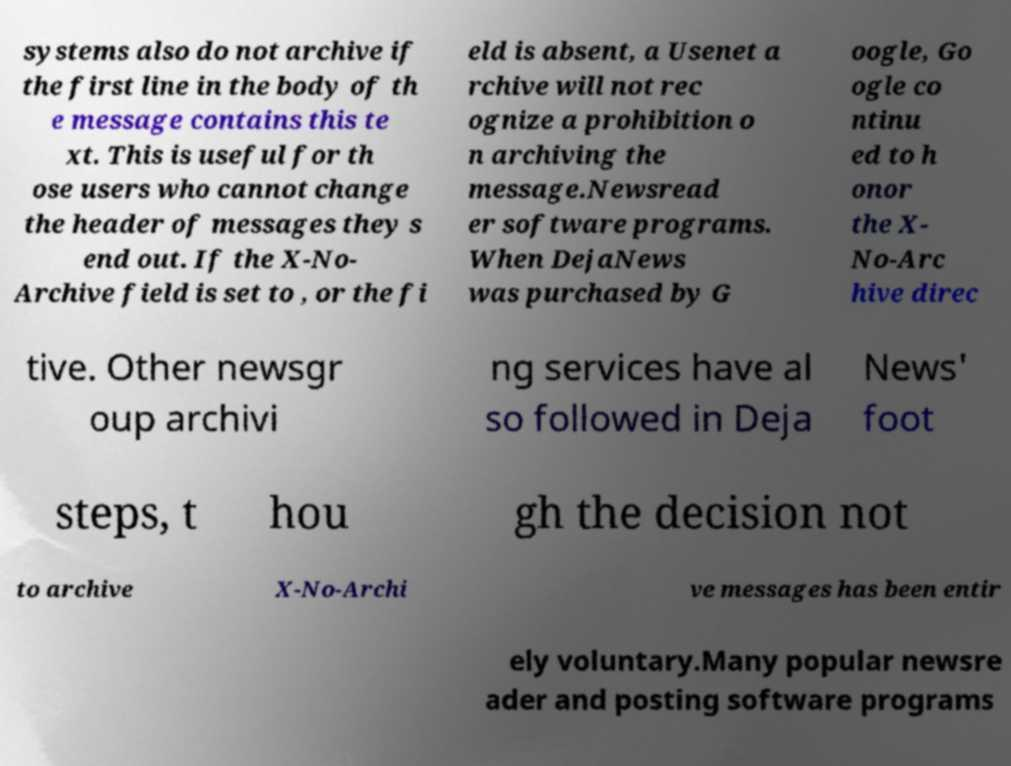There's text embedded in this image that I need extracted. Can you transcribe it verbatim? systems also do not archive if the first line in the body of th e message contains this te xt. This is useful for th ose users who cannot change the header of messages they s end out. If the X-No- Archive field is set to , or the fi eld is absent, a Usenet a rchive will not rec ognize a prohibition o n archiving the message.Newsread er software programs. When DejaNews was purchased by G oogle, Go ogle co ntinu ed to h onor the X- No-Arc hive direc tive. Other newsgr oup archivi ng services have al so followed in Deja News' foot steps, t hou gh the decision not to archive X-No-Archi ve messages has been entir ely voluntary.Many popular newsre ader and posting software programs 